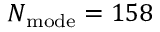Convert formula to latex. <formula><loc_0><loc_0><loc_500><loc_500>N _ { m o d e } = 1 5 8</formula> 